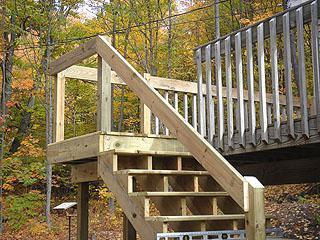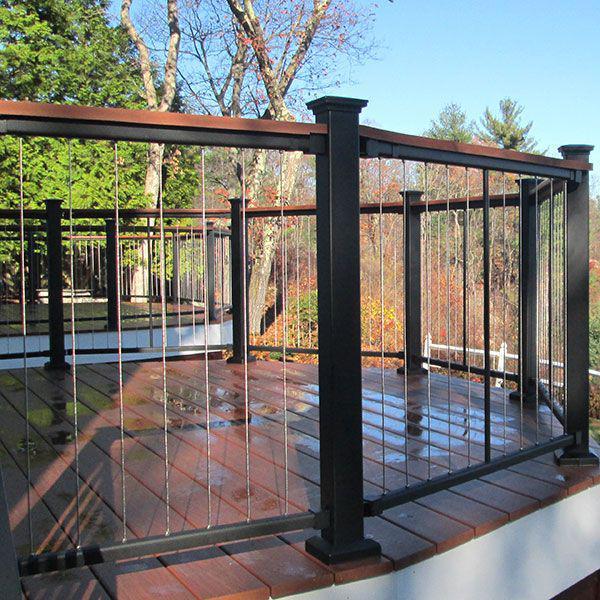The first image is the image on the left, the second image is the image on the right. For the images shown, is this caption "An image includes ascending stairs with dark brown rails and dark bars, and square corner posts with no lights on top." true? Answer yes or no. No. The first image is the image on the left, the second image is the image on the right. Examine the images to the left and right. Is the description "In at least one image there are at least 4 steps facing forward right at the bottom of the balcony." accurate? Answer yes or no. Yes. 